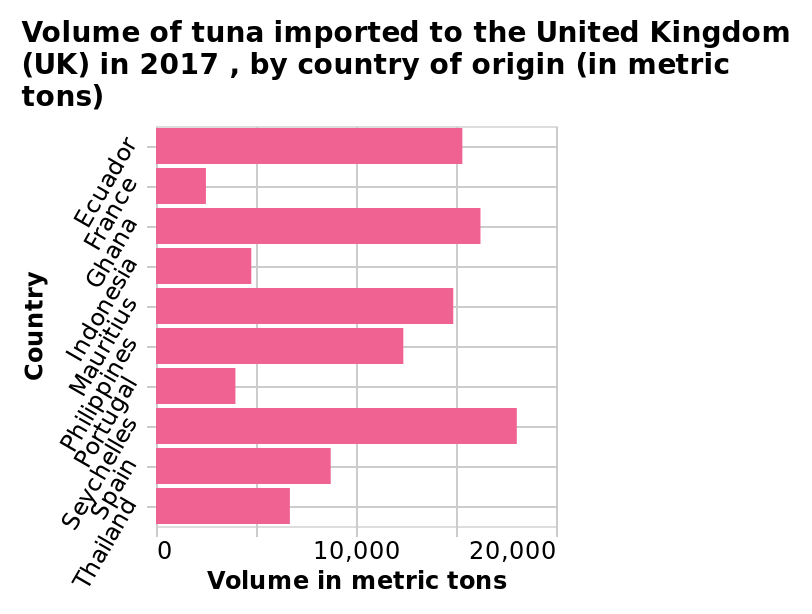<image>
Are the countries that supply the least tuna generally European?  Yes, the countries that supply the least tuna are generally European. What does the x-axis represent? The x-axis represents the volume of tuna imported in metric tons, ranging from 0 to 20,000. Which country provides the least tuna?  France provides the least tuna. Is there a significant difference in import amounts between countries?  Yes, there is a significant difference in import amounts between countries. 